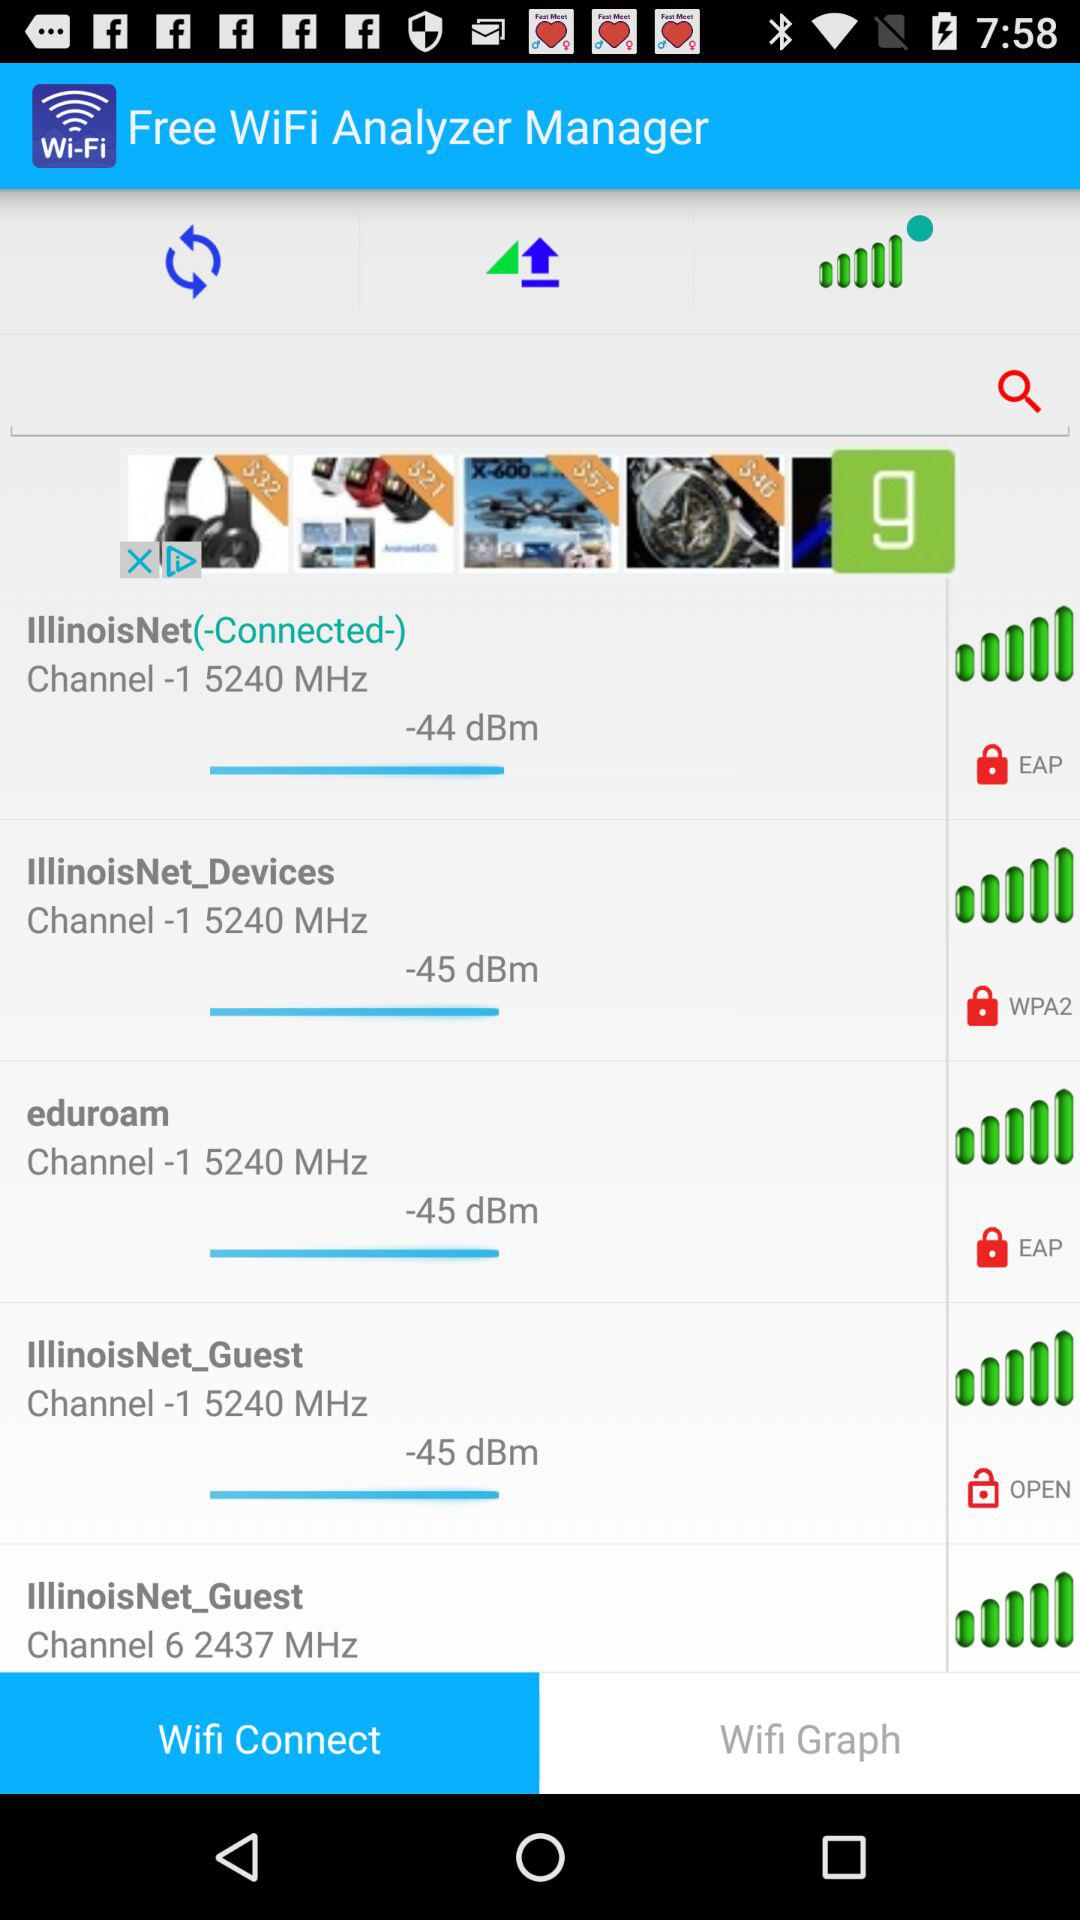Which WiFi is connected? The connected WiFi is "IllinoisNet". 